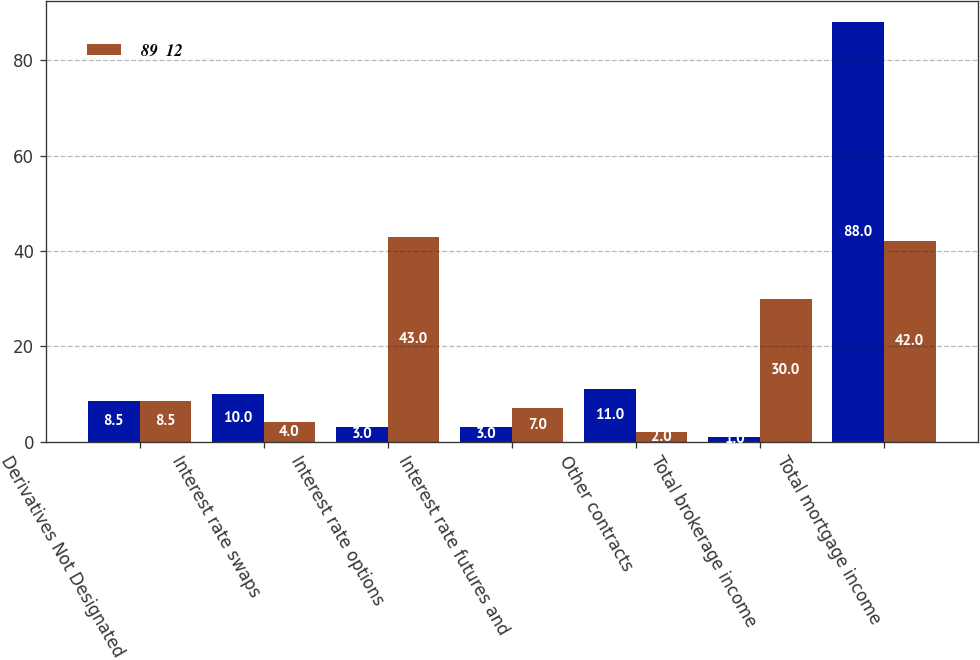<chart> <loc_0><loc_0><loc_500><loc_500><stacked_bar_chart><ecel><fcel>Derivatives Not Designated as<fcel>Interest rate swaps<fcel>Interest rate options<fcel>Interest rate futures and<fcel>Other contracts<fcel>Total brokerage income<fcel>Total mortgage income<nl><fcel>nan<fcel>8.5<fcel>10<fcel>3<fcel>3<fcel>11<fcel>1<fcel>88<nl><fcel>89  12<fcel>8.5<fcel>4<fcel>43<fcel>7<fcel>2<fcel>30<fcel>42<nl></chart> 